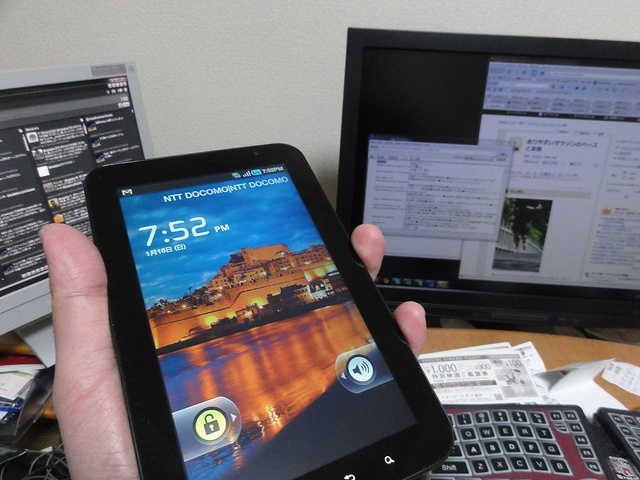Describe the objects in this image and their specific colors. I can see cell phone in darkgray, black, brown, gray, and blue tones, tv in darkgray, black, and gray tones, tv in darkgray, black, and gray tones, people in darkgray, lightpink, and gray tones, and keyboard in darkgray, black, gray, and brown tones in this image. 